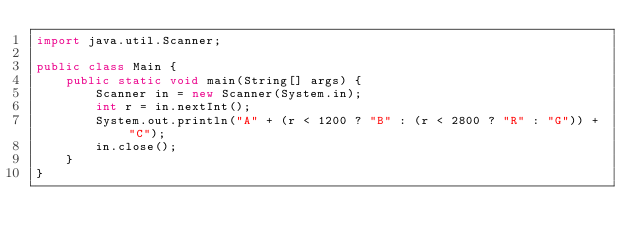Convert code to text. <code><loc_0><loc_0><loc_500><loc_500><_Java_>import java.util.Scanner;

public class Main {
    public static void main(String[] args) {
        Scanner in = new Scanner(System.in);
        int r = in.nextInt();
        System.out.println("A" + (r < 1200 ? "B" : (r < 2800 ? "R" : "G")) + "C");
        in.close();
    }
}</code> 